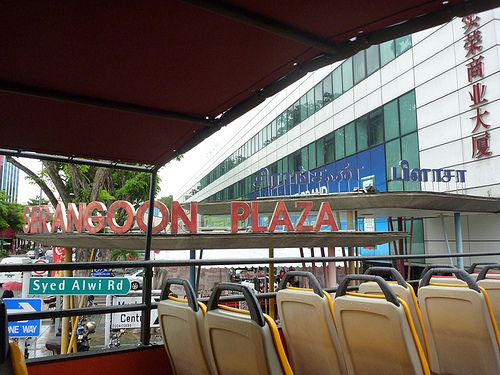<image>
Can you confirm if the sign is on the chair? No. The sign is not positioned on the chair. They may be near each other, but the sign is not supported by or resting on top of the chair. 